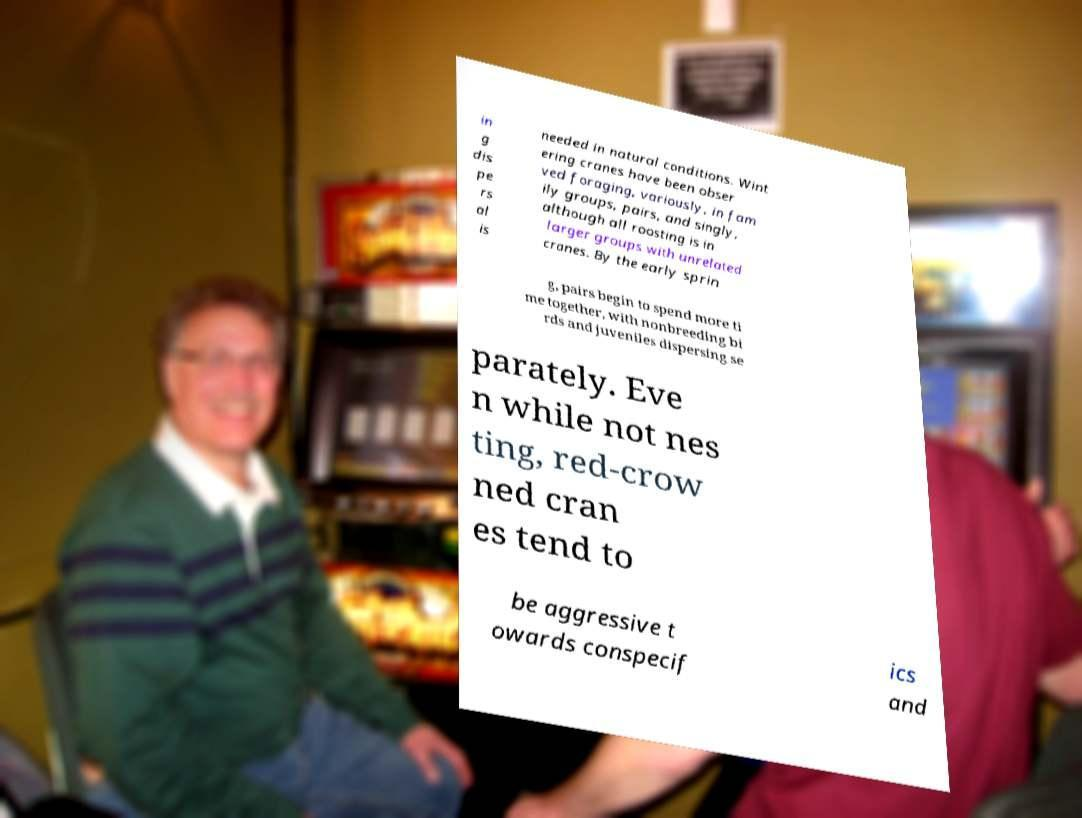Can you accurately transcribe the text from the provided image for me? in g dis pe rs al is needed in natural conditions. Wint ering cranes have been obser ved foraging, variously, in fam ily groups, pairs, and singly, although all roosting is in larger groups with unrelated cranes. By the early sprin g, pairs begin to spend more ti me together, with nonbreeding bi rds and juveniles dispersing se parately. Eve n while not nes ting, red-crow ned cran es tend to be aggressive t owards conspecif ics and 